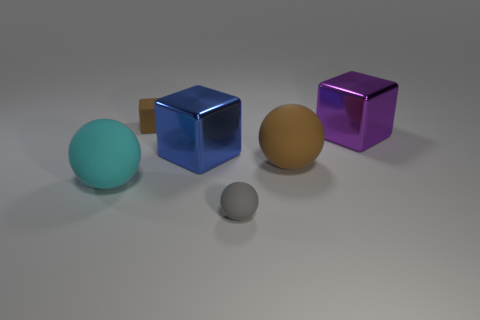Add 3 big spheres. How many objects exist? 9 Subtract 0 green balls. How many objects are left? 6 Subtract all big gray metallic objects. Subtract all cyan things. How many objects are left? 5 Add 3 purple metallic cubes. How many purple metallic cubes are left? 4 Add 6 green matte spheres. How many green matte spheres exist? 6 